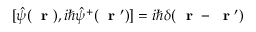<formula> <loc_0><loc_0><loc_500><loc_500>[ \hat { \psi } ( r ) , i \hbar { \hat } { \psi } ^ { + } ( r ^ { \prime } ) ] = i \hbar { \delta } ( r - r ^ { \prime } )</formula> 